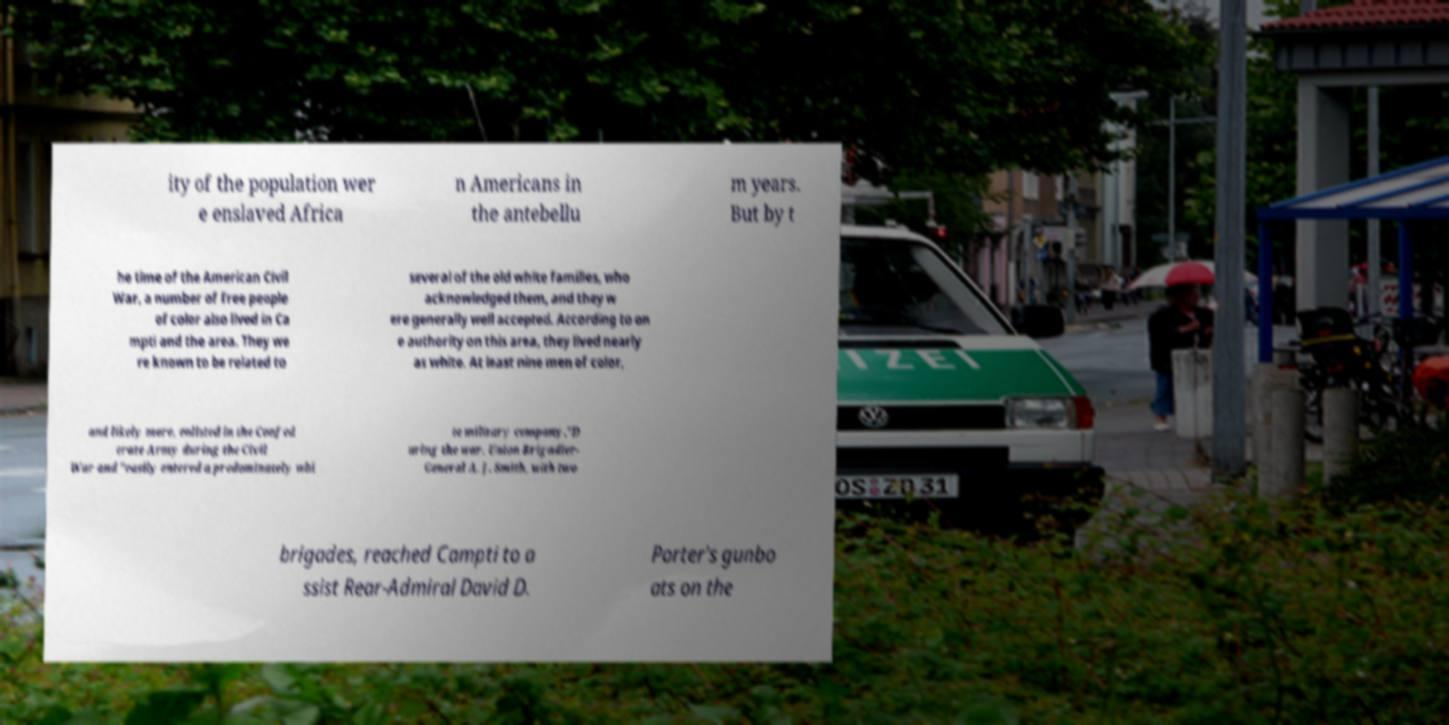There's text embedded in this image that I need extracted. Can you transcribe it verbatim? ity of the population wer e enslaved Africa n Americans in the antebellu m years. But by t he time of the American Civil War, a number of free people of color also lived in Ca mpti and the area. They we re known to be related to several of the old white families, who acknowledged them, and they w ere generally well accepted. According to on e authority on this area, they lived nearly as white. At least nine men of color, and likely more, enlisted in the Confed erate Army during the Civil War and "easily entered a predominately whi te military company."D uring the war, Union Brigadier- General A. J. Smith, with two brigades, reached Campti to a ssist Rear-Admiral David D. Porter's gunbo ats on the 